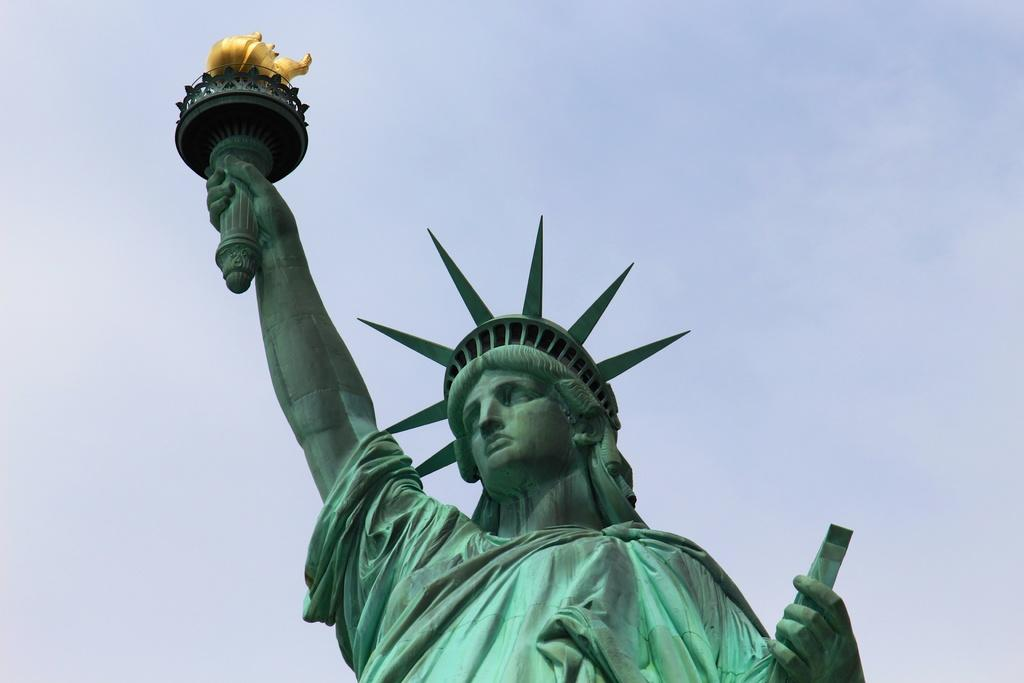What is the main subject of the image? There is a statue of liberty in the image. What can be seen in the background of the image? The sky is visible in the background of the image. What type of bottle is the Statue of Liberty holding in the image? The Statue of Liberty is not holding a bottle in the image. 